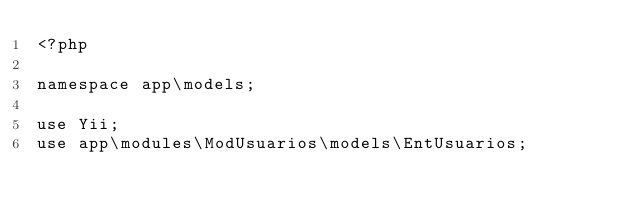Convert code to text. <code><loc_0><loc_0><loc_500><loc_500><_PHP_><?php

namespace app\models;

use Yii;
use app\modules\ModUsuarios\models\EntUsuarios;</code> 